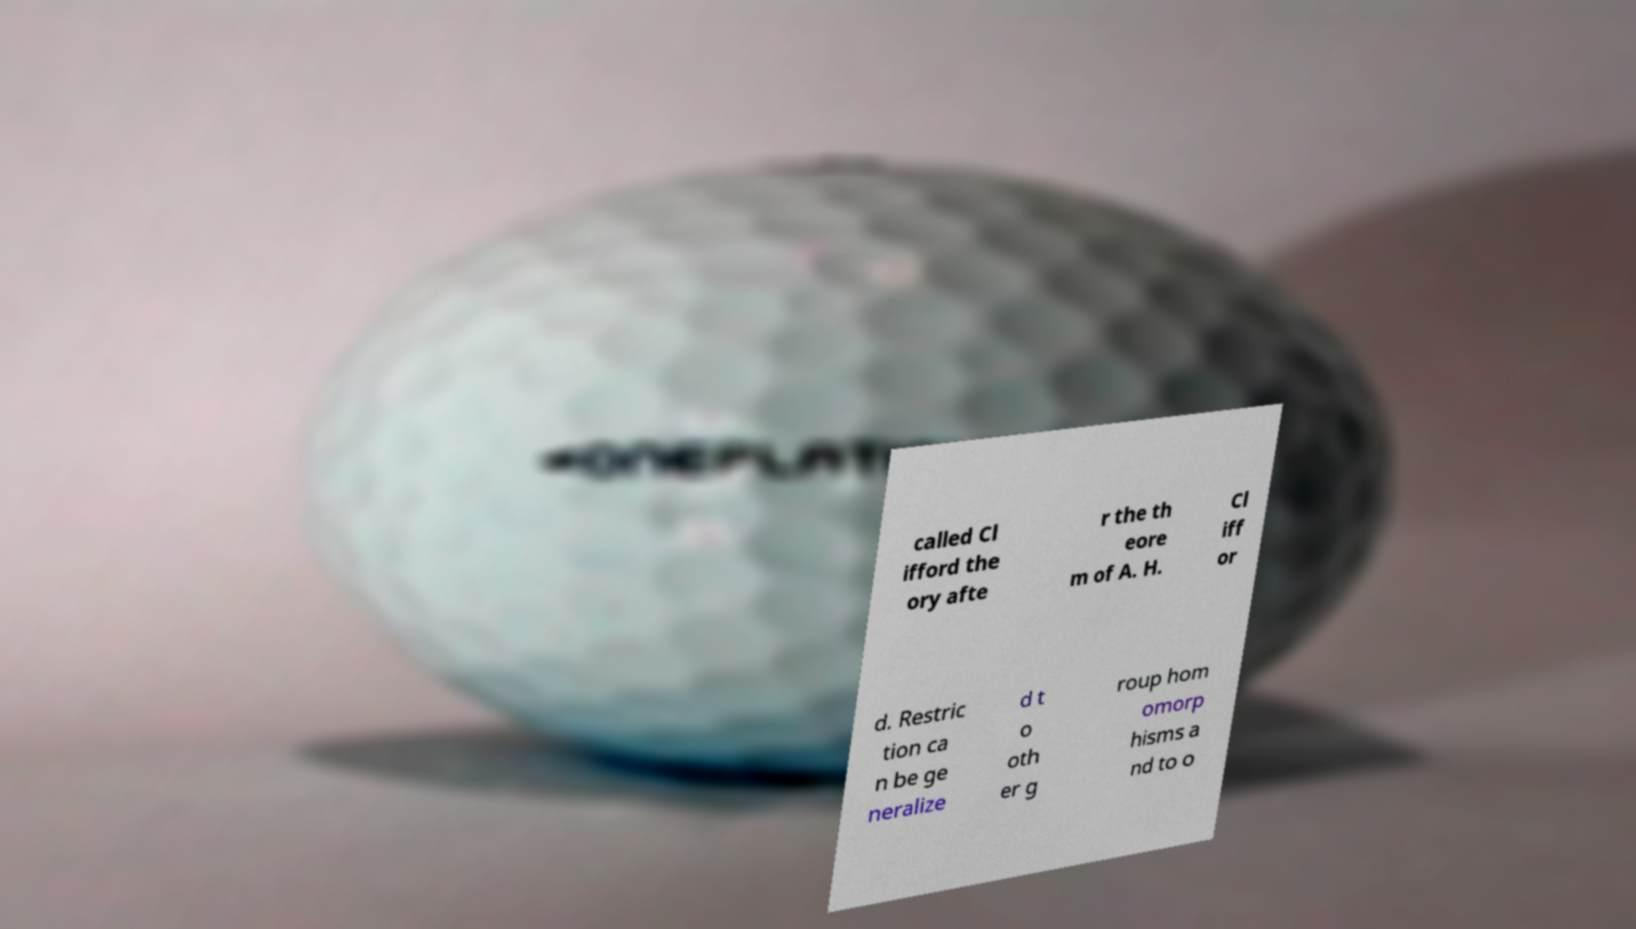What messages or text are displayed in this image? I need them in a readable, typed format. called Cl ifford the ory afte r the th eore m of A. H. Cl iff or d. Restric tion ca n be ge neralize d t o oth er g roup hom omorp hisms a nd to o 